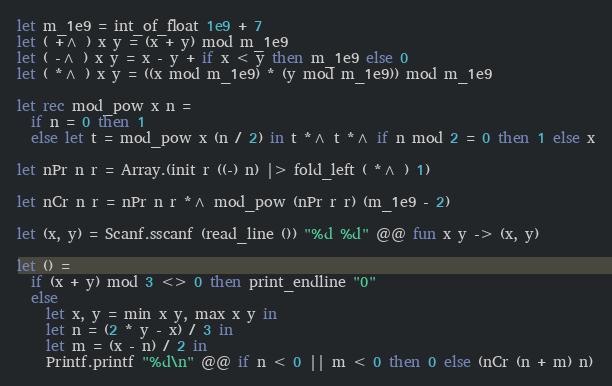<code> <loc_0><loc_0><loc_500><loc_500><_OCaml_>let m_1e9 = int_of_float 1e9 + 7
let ( +^ ) x y = (x + y) mod m_1e9
let ( -^ ) x y = x - y + if x < y then m_1e9 else 0
let ( *^ ) x y = ((x mod m_1e9) * (y mod m_1e9)) mod m_1e9

let rec mod_pow x n =
  if n = 0 then 1
  else let t = mod_pow x (n / 2) in t *^ t *^ if n mod 2 = 0 then 1 else x

let nPr n r = Array.(init r ((-) n) |> fold_left ( *^ ) 1)

let nCr n r = nPr n r *^ mod_pow (nPr r r) (m_1e9 - 2)

let (x, y) = Scanf.sscanf (read_line ()) "%d %d" @@ fun x y -> (x, y)

let () =
  if (x + y) mod 3 <> 0 then print_endline "0"
  else
    let x, y = min x y, max x y in
    let n = (2 * y - x) / 3 in
    let m = (x - n) / 2 in
    Printf.printf "%d\n" @@ if n < 0 || m < 0 then 0 else (nCr (n + m) n)</code> 